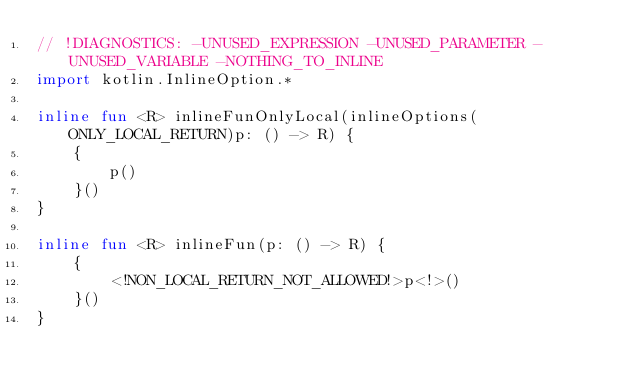Convert code to text. <code><loc_0><loc_0><loc_500><loc_500><_Kotlin_>// !DIAGNOSTICS: -UNUSED_EXPRESSION -UNUSED_PARAMETER -UNUSED_VARIABLE -NOTHING_TO_INLINE
import kotlin.InlineOption.*

inline fun <R> inlineFunOnlyLocal(inlineOptions(ONLY_LOCAL_RETURN)p: () -> R) {
    {
        p()
    }()
}

inline fun <R> inlineFun(p: () -> R) {
    {
        <!NON_LOCAL_RETURN_NOT_ALLOWED!>p<!>()
    }()
}</code> 